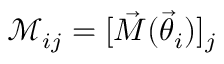<formula> <loc_0><loc_0><loc_500><loc_500>\mathcal { M } _ { i j } = [ \vec { M } ( \vec { \theta } _ { i } ) ] _ { j }</formula> 